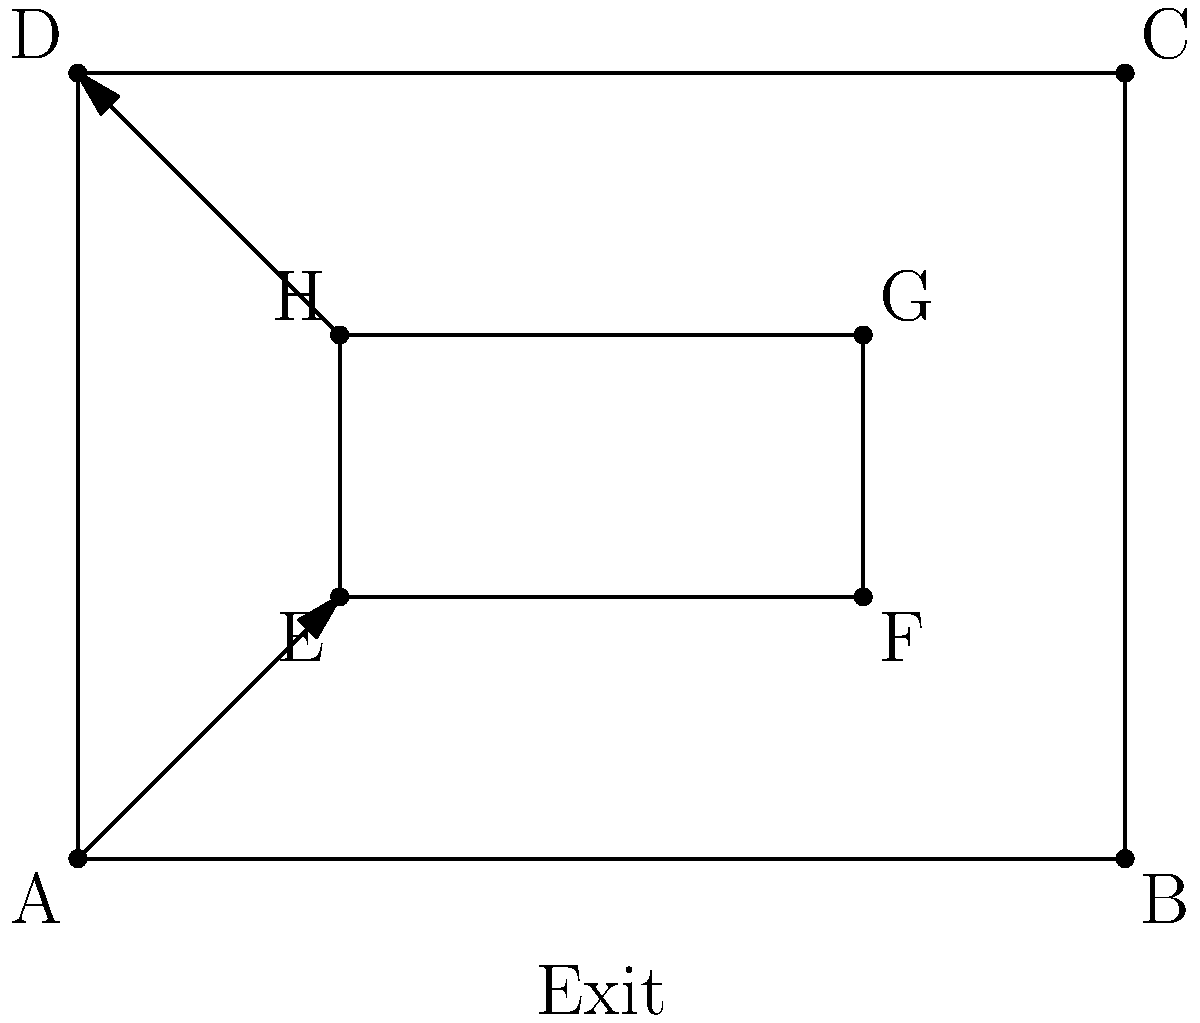In your latest mystery novel, the protagonist needs to escape a building during a tense climax. Given the floor plan above, where A, B, C, and D represent the corners of the building, and E, F, G, H represent an inner room, what is the optimal escape route vector from point E to the exit, assuming the character can only move in straight lines? To find the optimal escape route vector, we need to follow these steps:

1. Identify the starting point: E(1,1)
2. Identify the exit point: midpoint of AB, which is (2,0)
3. Calculate the vector from E to the exit:
   
   $$\vec{v} = (2,0) - (1,1) = (1,-1)$$

4. Normalize the vector to get a unit vector:
   
   $$\|\vec{v}\| = \sqrt{1^2 + (-1)^2} = \sqrt{2}$$
   
   $$\hat{v} = \frac{\vec{v}}{\|\vec{v}\|} = (\frac{1}{\sqrt{2}}, -\frac{1}{\sqrt{2}})$$

5. The optimal escape route vector is this unit vector, which represents the direction of the shortest path from E to the exit.

This vector guides the character diagonally from E to the exit, avoiding obstacles and providing the most direct route for a dramatic escape scene.
Answer: $(\frac{1}{\sqrt{2}}, -\frac{1}{\sqrt{2}})$ 